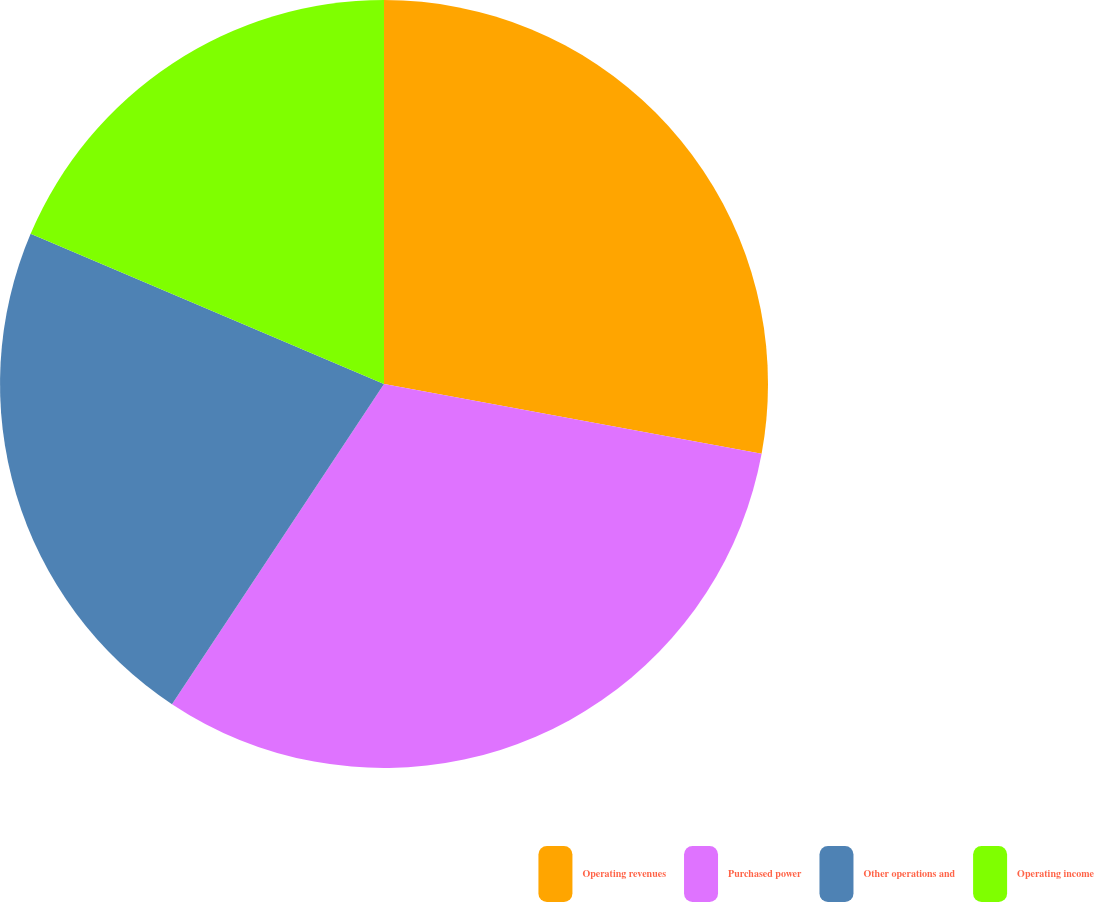Convert chart. <chart><loc_0><loc_0><loc_500><loc_500><pie_chart><fcel>Operating revenues<fcel>Purchased power<fcel>Other operations and<fcel>Operating income<nl><fcel>27.91%<fcel>31.4%<fcel>22.09%<fcel>18.6%<nl></chart> 